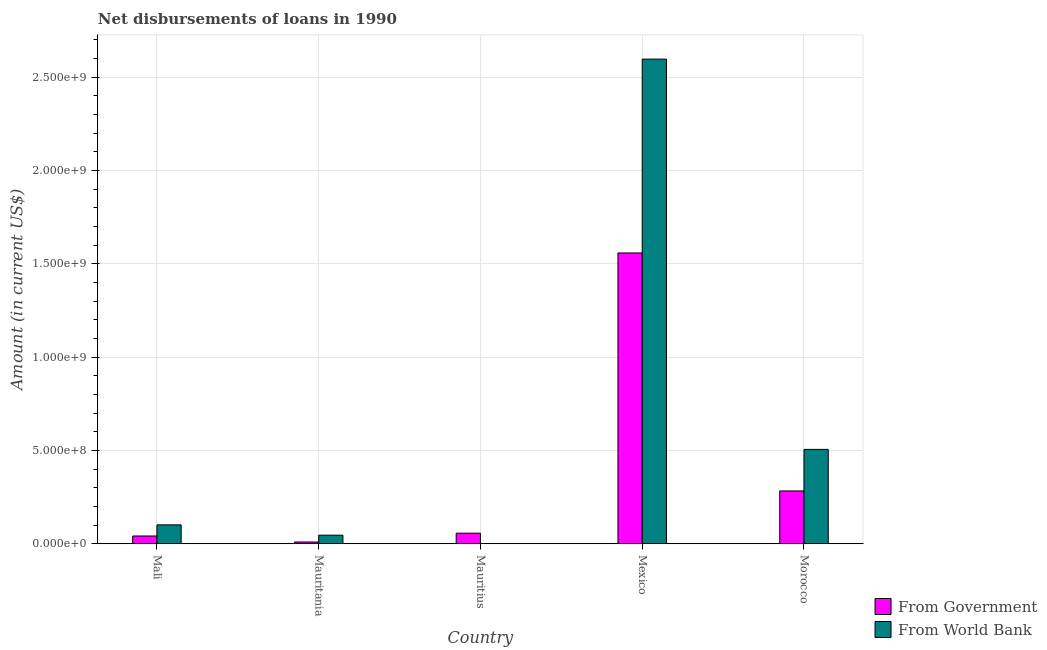How many different coloured bars are there?
Your response must be concise. 2. Are the number of bars per tick equal to the number of legend labels?
Ensure brevity in your answer.  Yes. Are the number of bars on each tick of the X-axis equal?
Your response must be concise. Yes. What is the label of the 3rd group of bars from the left?
Keep it short and to the point. Mauritius. In how many cases, is the number of bars for a given country not equal to the number of legend labels?
Your answer should be very brief. 0. What is the net disbursements of loan from world bank in Morocco?
Offer a very short reply. 5.06e+08. Across all countries, what is the maximum net disbursements of loan from world bank?
Your answer should be very brief. 2.60e+09. Across all countries, what is the minimum net disbursements of loan from government?
Your answer should be compact. 9.43e+06. In which country was the net disbursements of loan from world bank minimum?
Your answer should be very brief. Mauritius. What is the total net disbursements of loan from government in the graph?
Offer a terse response. 1.95e+09. What is the difference between the net disbursements of loan from world bank in Mauritania and that in Mexico?
Offer a very short reply. -2.55e+09. What is the difference between the net disbursements of loan from world bank in Mauritania and the net disbursements of loan from government in Morocco?
Your answer should be very brief. -2.37e+08. What is the average net disbursements of loan from world bank per country?
Give a very brief answer. 6.50e+08. What is the difference between the net disbursements of loan from world bank and net disbursements of loan from government in Morocco?
Keep it short and to the point. 2.23e+08. In how many countries, is the net disbursements of loan from world bank greater than 1000000000 US$?
Your answer should be compact. 1. What is the ratio of the net disbursements of loan from government in Mali to that in Mauritius?
Offer a terse response. 0.73. Is the difference between the net disbursements of loan from world bank in Mauritius and Mexico greater than the difference between the net disbursements of loan from government in Mauritius and Mexico?
Make the answer very short. No. What is the difference between the highest and the second highest net disbursements of loan from world bank?
Offer a terse response. 2.09e+09. What is the difference between the highest and the lowest net disbursements of loan from government?
Make the answer very short. 1.55e+09. In how many countries, is the net disbursements of loan from world bank greater than the average net disbursements of loan from world bank taken over all countries?
Your response must be concise. 1. What does the 1st bar from the left in Mauritania represents?
Give a very brief answer. From Government. What does the 1st bar from the right in Mauritius represents?
Make the answer very short. From World Bank. Are the values on the major ticks of Y-axis written in scientific E-notation?
Your answer should be very brief. Yes. Where does the legend appear in the graph?
Your answer should be compact. Bottom right. How many legend labels are there?
Your response must be concise. 2. How are the legend labels stacked?
Provide a short and direct response. Vertical. What is the title of the graph?
Ensure brevity in your answer.  Net disbursements of loans in 1990. Does "Urban agglomerations" appear as one of the legend labels in the graph?
Offer a very short reply. No. What is the Amount (in current US$) in From Government in Mali?
Provide a short and direct response. 4.15e+07. What is the Amount (in current US$) in From World Bank in Mali?
Make the answer very short. 1.01e+08. What is the Amount (in current US$) in From Government in Mauritania?
Give a very brief answer. 9.43e+06. What is the Amount (in current US$) in From World Bank in Mauritania?
Keep it short and to the point. 4.58e+07. What is the Amount (in current US$) in From Government in Mauritius?
Your answer should be compact. 5.66e+07. What is the Amount (in current US$) in From Government in Mexico?
Provide a succinct answer. 1.56e+09. What is the Amount (in current US$) in From World Bank in Mexico?
Your response must be concise. 2.60e+09. What is the Amount (in current US$) in From Government in Morocco?
Keep it short and to the point. 2.83e+08. What is the Amount (in current US$) in From World Bank in Morocco?
Offer a very short reply. 5.06e+08. Across all countries, what is the maximum Amount (in current US$) in From Government?
Make the answer very short. 1.56e+09. Across all countries, what is the maximum Amount (in current US$) of From World Bank?
Your answer should be compact. 2.60e+09. Across all countries, what is the minimum Amount (in current US$) in From Government?
Make the answer very short. 9.43e+06. Across all countries, what is the minimum Amount (in current US$) of From World Bank?
Ensure brevity in your answer.  2.60e+05. What is the total Amount (in current US$) of From Government in the graph?
Your answer should be compact. 1.95e+09. What is the total Amount (in current US$) in From World Bank in the graph?
Your answer should be compact. 3.25e+09. What is the difference between the Amount (in current US$) in From Government in Mali and that in Mauritania?
Your response must be concise. 3.21e+07. What is the difference between the Amount (in current US$) of From World Bank in Mali and that in Mauritania?
Keep it short and to the point. 5.54e+07. What is the difference between the Amount (in current US$) of From Government in Mali and that in Mauritius?
Offer a terse response. -1.51e+07. What is the difference between the Amount (in current US$) in From World Bank in Mali and that in Mauritius?
Offer a terse response. 1.01e+08. What is the difference between the Amount (in current US$) of From Government in Mali and that in Mexico?
Provide a short and direct response. -1.52e+09. What is the difference between the Amount (in current US$) of From World Bank in Mali and that in Mexico?
Offer a terse response. -2.50e+09. What is the difference between the Amount (in current US$) in From Government in Mali and that in Morocco?
Provide a succinct answer. -2.41e+08. What is the difference between the Amount (in current US$) of From World Bank in Mali and that in Morocco?
Offer a very short reply. -4.04e+08. What is the difference between the Amount (in current US$) of From Government in Mauritania and that in Mauritius?
Make the answer very short. -4.71e+07. What is the difference between the Amount (in current US$) in From World Bank in Mauritania and that in Mauritius?
Provide a short and direct response. 4.55e+07. What is the difference between the Amount (in current US$) of From Government in Mauritania and that in Mexico?
Your answer should be very brief. -1.55e+09. What is the difference between the Amount (in current US$) in From World Bank in Mauritania and that in Mexico?
Your answer should be very brief. -2.55e+09. What is the difference between the Amount (in current US$) of From Government in Mauritania and that in Morocco?
Your answer should be very brief. -2.74e+08. What is the difference between the Amount (in current US$) in From World Bank in Mauritania and that in Morocco?
Provide a succinct answer. -4.60e+08. What is the difference between the Amount (in current US$) in From Government in Mauritius and that in Mexico?
Your answer should be compact. -1.50e+09. What is the difference between the Amount (in current US$) in From World Bank in Mauritius and that in Mexico?
Offer a terse response. -2.60e+09. What is the difference between the Amount (in current US$) of From Government in Mauritius and that in Morocco?
Ensure brevity in your answer.  -2.26e+08. What is the difference between the Amount (in current US$) in From World Bank in Mauritius and that in Morocco?
Provide a succinct answer. -5.05e+08. What is the difference between the Amount (in current US$) of From Government in Mexico and that in Morocco?
Give a very brief answer. 1.28e+09. What is the difference between the Amount (in current US$) of From World Bank in Mexico and that in Morocco?
Offer a terse response. 2.09e+09. What is the difference between the Amount (in current US$) of From Government in Mali and the Amount (in current US$) of From World Bank in Mauritania?
Your answer should be very brief. -4.28e+06. What is the difference between the Amount (in current US$) of From Government in Mali and the Amount (in current US$) of From World Bank in Mauritius?
Give a very brief answer. 4.13e+07. What is the difference between the Amount (in current US$) in From Government in Mali and the Amount (in current US$) in From World Bank in Mexico?
Give a very brief answer. -2.56e+09. What is the difference between the Amount (in current US$) in From Government in Mali and the Amount (in current US$) in From World Bank in Morocco?
Provide a short and direct response. -4.64e+08. What is the difference between the Amount (in current US$) of From Government in Mauritania and the Amount (in current US$) of From World Bank in Mauritius?
Provide a short and direct response. 9.17e+06. What is the difference between the Amount (in current US$) of From Government in Mauritania and the Amount (in current US$) of From World Bank in Mexico?
Offer a terse response. -2.59e+09. What is the difference between the Amount (in current US$) in From Government in Mauritania and the Amount (in current US$) in From World Bank in Morocco?
Give a very brief answer. -4.96e+08. What is the difference between the Amount (in current US$) in From Government in Mauritius and the Amount (in current US$) in From World Bank in Mexico?
Your answer should be very brief. -2.54e+09. What is the difference between the Amount (in current US$) in From Government in Mauritius and the Amount (in current US$) in From World Bank in Morocco?
Provide a short and direct response. -4.49e+08. What is the difference between the Amount (in current US$) in From Government in Mexico and the Amount (in current US$) in From World Bank in Morocco?
Offer a terse response. 1.05e+09. What is the average Amount (in current US$) in From Government per country?
Your answer should be very brief. 3.90e+08. What is the average Amount (in current US$) of From World Bank per country?
Make the answer very short. 6.50e+08. What is the difference between the Amount (in current US$) in From Government and Amount (in current US$) in From World Bank in Mali?
Provide a short and direct response. -5.97e+07. What is the difference between the Amount (in current US$) in From Government and Amount (in current US$) in From World Bank in Mauritania?
Provide a short and direct response. -3.64e+07. What is the difference between the Amount (in current US$) in From Government and Amount (in current US$) in From World Bank in Mauritius?
Keep it short and to the point. 5.63e+07. What is the difference between the Amount (in current US$) of From Government and Amount (in current US$) of From World Bank in Mexico?
Make the answer very short. -1.04e+09. What is the difference between the Amount (in current US$) of From Government and Amount (in current US$) of From World Bank in Morocco?
Provide a short and direct response. -2.23e+08. What is the ratio of the Amount (in current US$) in From Government in Mali to that in Mauritania?
Your answer should be compact. 4.4. What is the ratio of the Amount (in current US$) in From World Bank in Mali to that in Mauritania?
Offer a very short reply. 2.21. What is the ratio of the Amount (in current US$) of From Government in Mali to that in Mauritius?
Your response must be concise. 0.73. What is the ratio of the Amount (in current US$) in From World Bank in Mali to that in Mauritius?
Ensure brevity in your answer.  389.28. What is the ratio of the Amount (in current US$) of From Government in Mali to that in Mexico?
Keep it short and to the point. 0.03. What is the ratio of the Amount (in current US$) in From World Bank in Mali to that in Mexico?
Provide a short and direct response. 0.04. What is the ratio of the Amount (in current US$) in From Government in Mali to that in Morocco?
Your answer should be very brief. 0.15. What is the ratio of the Amount (in current US$) in From World Bank in Mali to that in Morocco?
Your answer should be very brief. 0.2. What is the ratio of the Amount (in current US$) in From Government in Mauritania to that in Mauritius?
Your answer should be very brief. 0.17. What is the ratio of the Amount (in current US$) in From World Bank in Mauritania to that in Mauritius?
Give a very brief answer. 176.12. What is the ratio of the Amount (in current US$) in From Government in Mauritania to that in Mexico?
Provide a short and direct response. 0.01. What is the ratio of the Amount (in current US$) of From World Bank in Mauritania to that in Mexico?
Offer a terse response. 0.02. What is the ratio of the Amount (in current US$) in From Government in Mauritania to that in Morocco?
Provide a short and direct response. 0.03. What is the ratio of the Amount (in current US$) of From World Bank in Mauritania to that in Morocco?
Ensure brevity in your answer.  0.09. What is the ratio of the Amount (in current US$) in From Government in Mauritius to that in Mexico?
Give a very brief answer. 0.04. What is the ratio of the Amount (in current US$) of From Government in Mauritius to that in Morocco?
Your answer should be very brief. 0.2. What is the ratio of the Amount (in current US$) in From World Bank in Mauritius to that in Morocco?
Offer a very short reply. 0. What is the ratio of the Amount (in current US$) of From Government in Mexico to that in Morocco?
Make the answer very short. 5.51. What is the ratio of the Amount (in current US$) in From World Bank in Mexico to that in Morocco?
Make the answer very short. 5.14. What is the difference between the highest and the second highest Amount (in current US$) in From Government?
Your answer should be very brief. 1.28e+09. What is the difference between the highest and the second highest Amount (in current US$) of From World Bank?
Offer a terse response. 2.09e+09. What is the difference between the highest and the lowest Amount (in current US$) of From Government?
Keep it short and to the point. 1.55e+09. What is the difference between the highest and the lowest Amount (in current US$) in From World Bank?
Your answer should be very brief. 2.60e+09. 